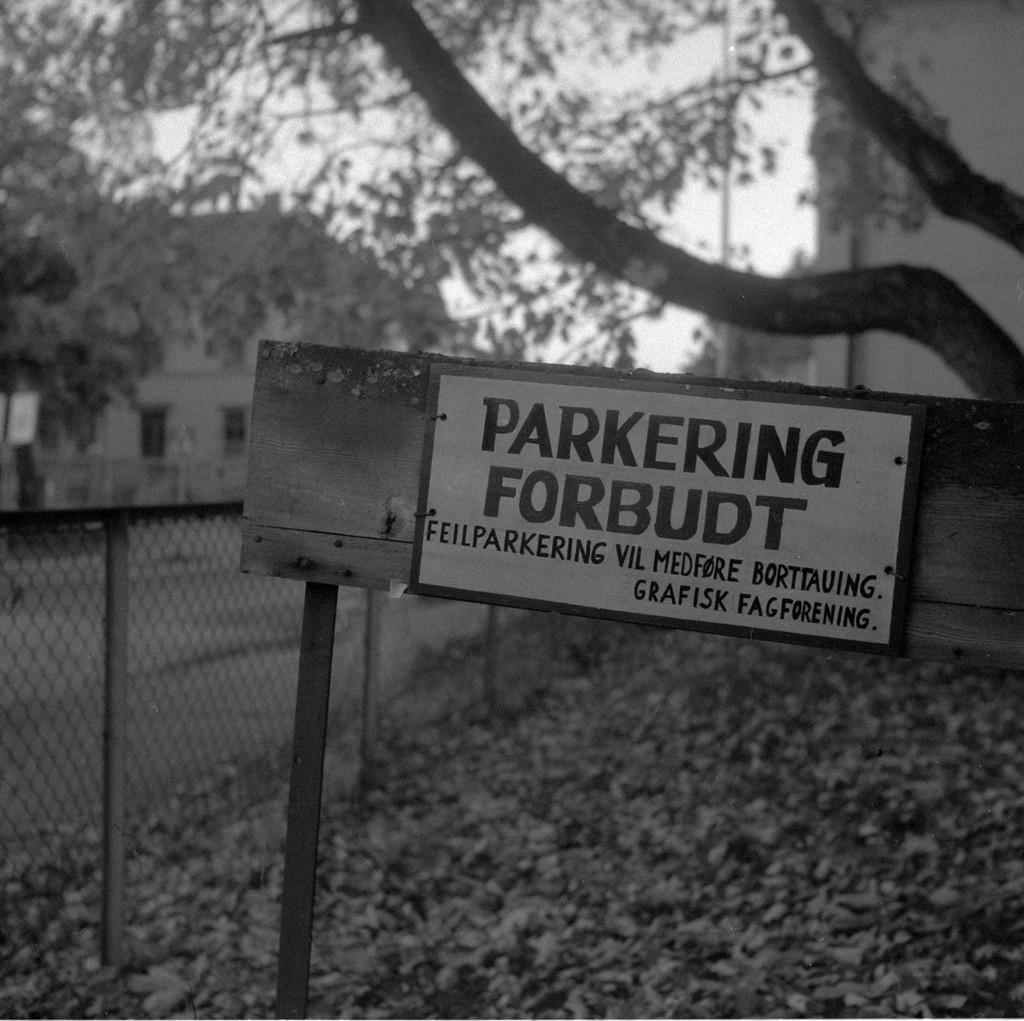What is the main object in the image? There is a name board in the image. What can be seen on the ground in the image? Dried leaves are present in the image. What type of barrier is visible in the image? There is a fence in the image. What is located beside the fence? A road is visible beside the fence. What type of structures are present in the image? There are buildings in the image. What type of vegetation is present in the image? Trees are present in the image. What is visible in the background of the image? The sky is visible in the background of the image. What type of stone is being used to make the cabbage in the image? There is no stone or cabbage present in the image. What type of plastic material is visible in the image? There is no plastic material visible in the image. 